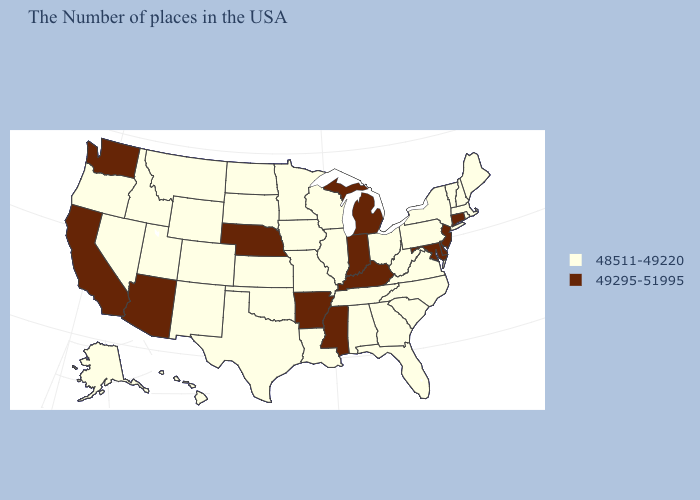Does Idaho have the same value as California?
Answer briefly. No. What is the value of Colorado?
Short answer required. 48511-49220. What is the lowest value in states that border Maine?
Be succinct. 48511-49220. Name the states that have a value in the range 49295-51995?
Give a very brief answer. Connecticut, New Jersey, Delaware, Maryland, Michigan, Kentucky, Indiana, Mississippi, Arkansas, Nebraska, Arizona, California, Washington. Which states have the lowest value in the USA?
Concise answer only. Maine, Massachusetts, Rhode Island, New Hampshire, Vermont, New York, Pennsylvania, Virginia, North Carolina, South Carolina, West Virginia, Ohio, Florida, Georgia, Alabama, Tennessee, Wisconsin, Illinois, Louisiana, Missouri, Minnesota, Iowa, Kansas, Oklahoma, Texas, South Dakota, North Dakota, Wyoming, Colorado, New Mexico, Utah, Montana, Idaho, Nevada, Oregon, Alaska, Hawaii. Among the states that border West Virginia , does Pennsylvania have the lowest value?
Short answer required. Yes. Name the states that have a value in the range 49295-51995?
Give a very brief answer. Connecticut, New Jersey, Delaware, Maryland, Michigan, Kentucky, Indiana, Mississippi, Arkansas, Nebraska, Arizona, California, Washington. Which states have the lowest value in the USA?
Give a very brief answer. Maine, Massachusetts, Rhode Island, New Hampshire, Vermont, New York, Pennsylvania, Virginia, North Carolina, South Carolina, West Virginia, Ohio, Florida, Georgia, Alabama, Tennessee, Wisconsin, Illinois, Louisiana, Missouri, Minnesota, Iowa, Kansas, Oklahoma, Texas, South Dakota, North Dakota, Wyoming, Colorado, New Mexico, Utah, Montana, Idaho, Nevada, Oregon, Alaska, Hawaii. Which states have the lowest value in the USA?
Answer briefly. Maine, Massachusetts, Rhode Island, New Hampshire, Vermont, New York, Pennsylvania, Virginia, North Carolina, South Carolina, West Virginia, Ohio, Florida, Georgia, Alabama, Tennessee, Wisconsin, Illinois, Louisiana, Missouri, Minnesota, Iowa, Kansas, Oklahoma, Texas, South Dakota, North Dakota, Wyoming, Colorado, New Mexico, Utah, Montana, Idaho, Nevada, Oregon, Alaska, Hawaii. Does Arizona have the highest value in the USA?
Give a very brief answer. Yes. Does the map have missing data?
Answer briefly. No. Which states have the lowest value in the USA?
Answer briefly. Maine, Massachusetts, Rhode Island, New Hampshire, Vermont, New York, Pennsylvania, Virginia, North Carolina, South Carolina, West Virginia, Ohio, Florida, Georgia, Alabama, Tennessee, Wisconsin, Illinois, Louisiana, Missouri, Minnesota, Iowa, Kansas, Oklahoma, Texas, South Dakota, North Dakota, Wyoming, Colorado, New Mexico, Utah, Montana, Idaho, Nevada, Oregon, Alaska, Hawaii. How many symbols are there in the legend?
Write a very short answer. 2. Does the map have missing data?
Short answer required. No. What is the value of Tennessee?
Write a very short answer. 48511-49220. 